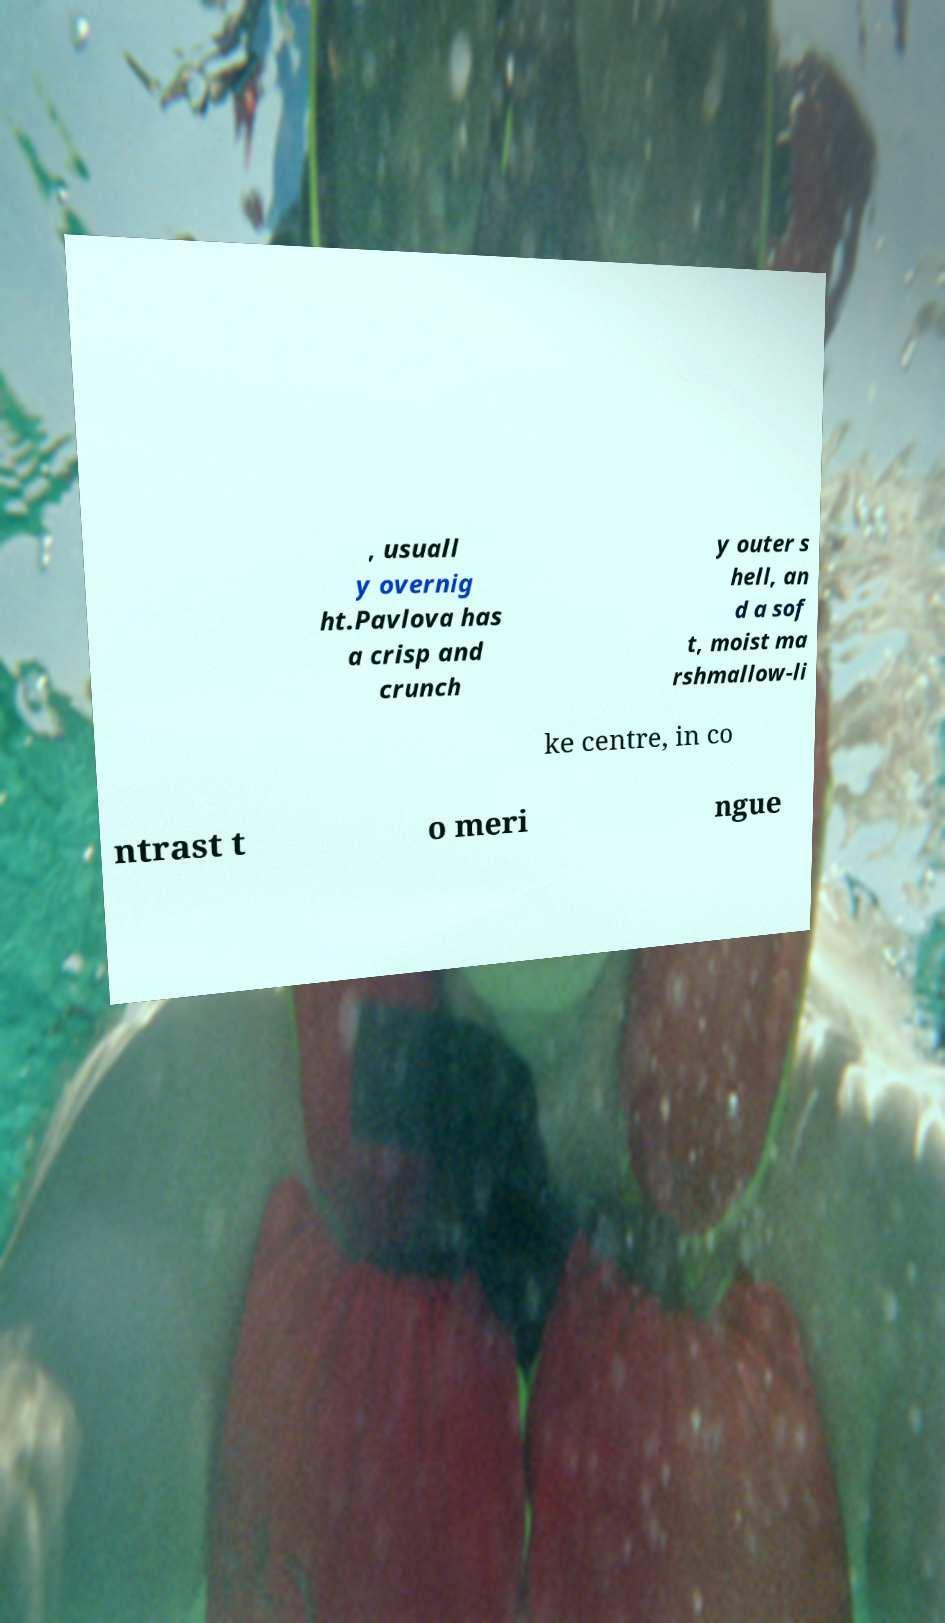There's text embedded in this image that I need extracted. Can you transcribe it verbatim? , usuall y overnig ht.Pavlova has a crisp and crunch y outer s hell, an d a sof t, moist ma rshmallow-li ke centre, in co ntrast t o meri ngue 